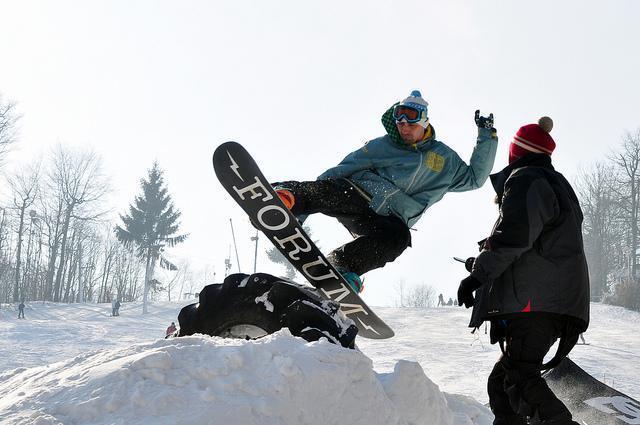How many people are there?
Give a very brief answer. 2. 